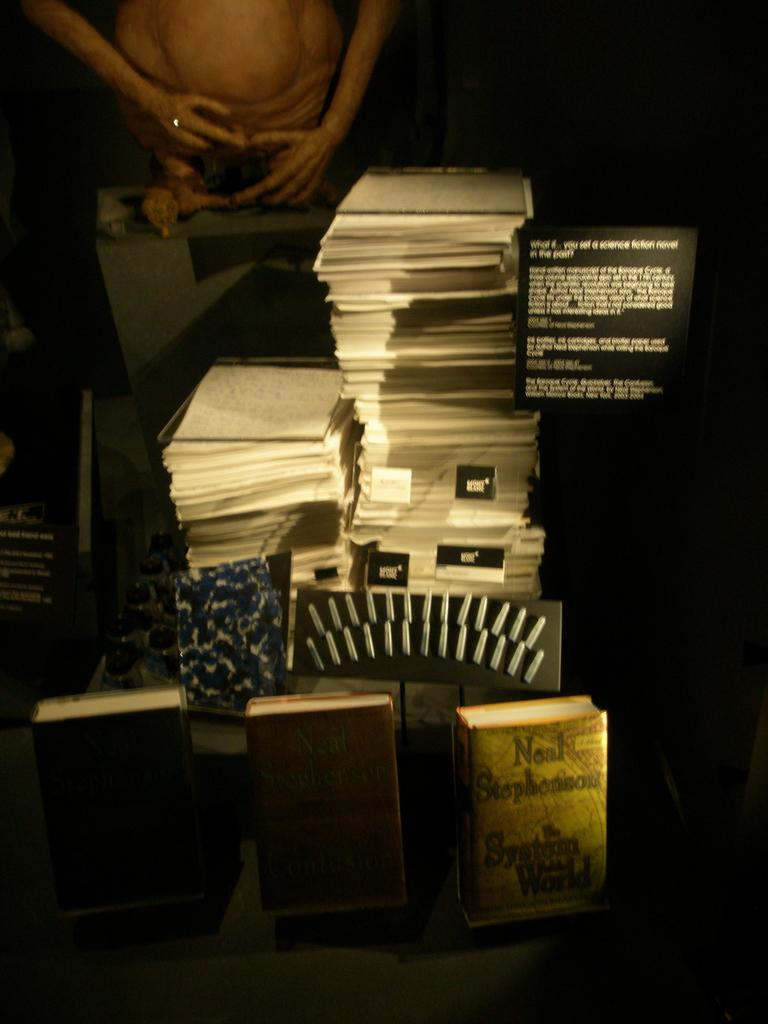<image>
Present a compact description of the photo's key features. A sign reading "what if you set a science fiction novel in the past?" sits near a stack of papers. 